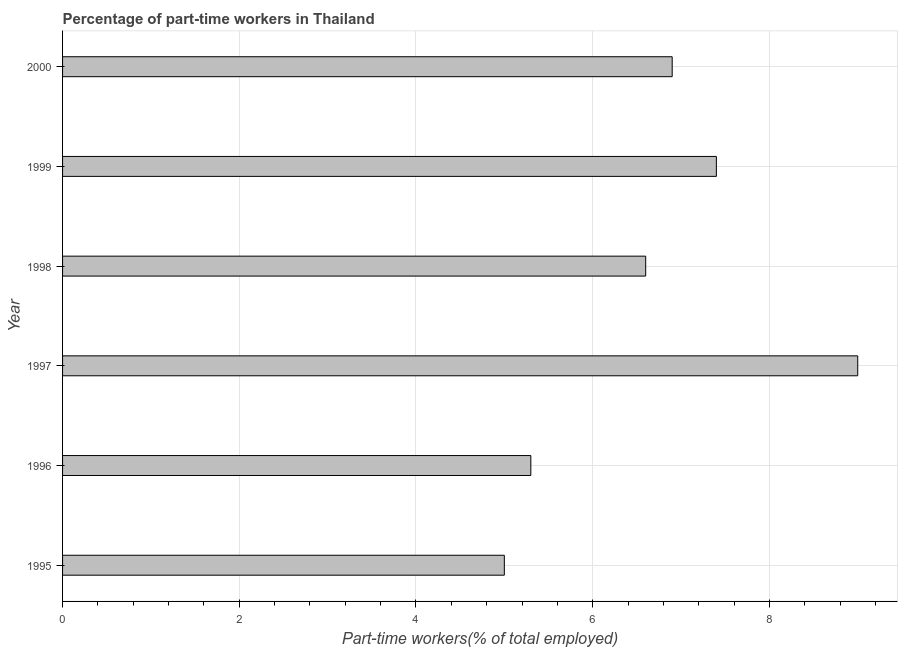Does the graph contain grids?
Your response must be concise. Yes. What is the title of the graph?
Your answer should be very brief. Percentage of part-time workers in Thailand. What is the label or title of the X-axis?
Give a very brief answer. Part-time workers(% of total employed). What is the sum of the percentage of part-time workers?
Your answer should be very brief. 40.2. What is the median percentage of part-time workers?
Give a very brief answer. 6.75. In how many years, is the percentage of part-time workers greater than 8 %?
Give a very brief answer. 1. Do a majority of the years between 1999 and 2000 (inclusive) have percentage of part-time workers greater than 3.2 %?
Ensure brevity in your answer.  Yes. What is the ratio of the percentage of part-time workers in 1999 to that in 2000?
Offer a terse response. 1.07. Is the percentage of part-time workers in 1997 less than that in 2000?
Keep it short and to the point. No. What is the difference between the highest and the second highest percentage of part-time workers?
Offer a very short reply. 1.6. Is the sum of the percentage of part-time workers in 1997 and 2000 greater than the maximum percentage of part-time workers across all years?
Your answer should be compact. Yes. What is the difference between the highest and the lowest percentage of part-time workers?
Your response must be concise. 4. How many bars are there?
Your answer should be very brief. 6. Are the values on the major ticks of X-axis written in scientific E-notation?
Give a very brief answer. No. What is the Part-time workers(% of total employed) of 1996?
Make the answer very short. 5.3. What is the Part-time workers(% of total employed) in 1998?
Ensure brevity in your answer.  6.6. What is the Part-time workers(% of total employed) in 1999?
Provide a succinct answer. 7.4. What is the Part-time workers(% of total employed) of 2000?
Make the answer very short. 6.9. What is the difference between the Part-time workers(% of total employed) in 1995 and 1997?
Provide a short and direct response. -4. What is the difference between the Part-time workers(% of total employed) in 1995 and 1998?
Offer a terse response. -1.6. What is the difference between the Part-time workers(% of total employed) in 1996 and 1998?
Offer a very short reply. -1.3. What is the difference between the Part-time workers(% of total employed) in 1996 and 2000?
Your response must be concise. -1.6. What is the difference between the Part-time workers(% of total employed) in 1997 and 1998?
Provide a succinct answer. 2.4. What is the difference between the Part-time workers(% of total employed) in 1997 and 2000?
Ensure brevity in your answer.  2.1. What is the difference between the Part-time workers(% of total employed) in 1998 and 1999?
Make the answer very short. -0.8. What is the difference between the Part-time workers(% of total employed) in 1998 and 2000?
Give a very brief answer. -0.3. What is the ratio of the Part-time workers(% of total employed) in 1995 to that in 1996?
Offer a terse response. 0.94. What is the ratio of the Part-time workers(% of total employed) in 1995 to that in 1997?
Make the answer very short. 0.56. What is the ratio of the Part-time workers(% of total employed) in 1995 to that in 1998?
Provide a succinct answer. 0.76. What is the ratio of the Part-time workers(% of total employed) in 1995 to that in 1999?
Keep it short and to the point. 0.68. What is the ratio of the Part-time workers(% of total employed) in 1995 to that in 2000?
Give a very brief answer. 0.72. What is the ratio of the Part-time workers(% of total employed) in 1996 to that in 1997?
Make the answer very short. 0.59. What is the ratio of the Part-time workers(% of total employed) in 1996 to that in 1998?
Offer a very short reply. 0.8. What is the ratio of the Part-time workers(% of total employed) in 1996 to that in 1999?
Your answer should be compact. 0.72. What is the ratio of the Part-time workers(% of total employed) in 1996 to that in 2000?
Ensure brevity in your answer.  0.77. What is the ratio of the Part-time workers(% of total employed) in 1997 to that in 1998?
Give a very brief answer. 1.36. What is the ratio of the Part-time workers(% of total employed) in 1997 to that in 1999?
Offer a very short reply. 1.22. What is the ratio of the Part-time workers(% of total employed) in 1997 to that in 2000?
Offer a terse response. 1.3. What is the ratio of the Part-time workers(% of total employed) in 1998 to that in 1999?
Your answer should be very brief. 0.89. What is the ratio of the Part-time workers(% of total employed) in 1999 to that in 2000?
Your answer should be very brief. 1.07. 